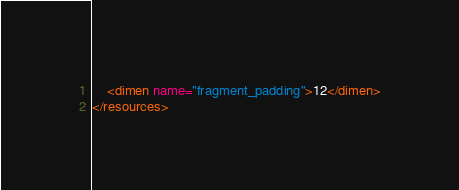Convert code to text. <code><loc_0><loc_0><loc_500><loc_500><_XML_>    <dimen name="fragment_padding">12</dimen>
</resources>
</code> 